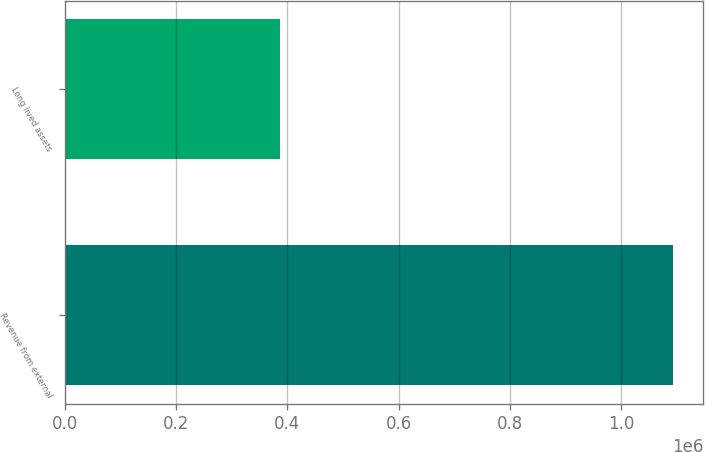<chart> <loc_0><loc_0><loc_500><loc_500><bar_chart><fcel>Revenue from external<fcel>Long lived assets<nl><fcel>1.09236e+06<fcel>387148<nl></chart> 